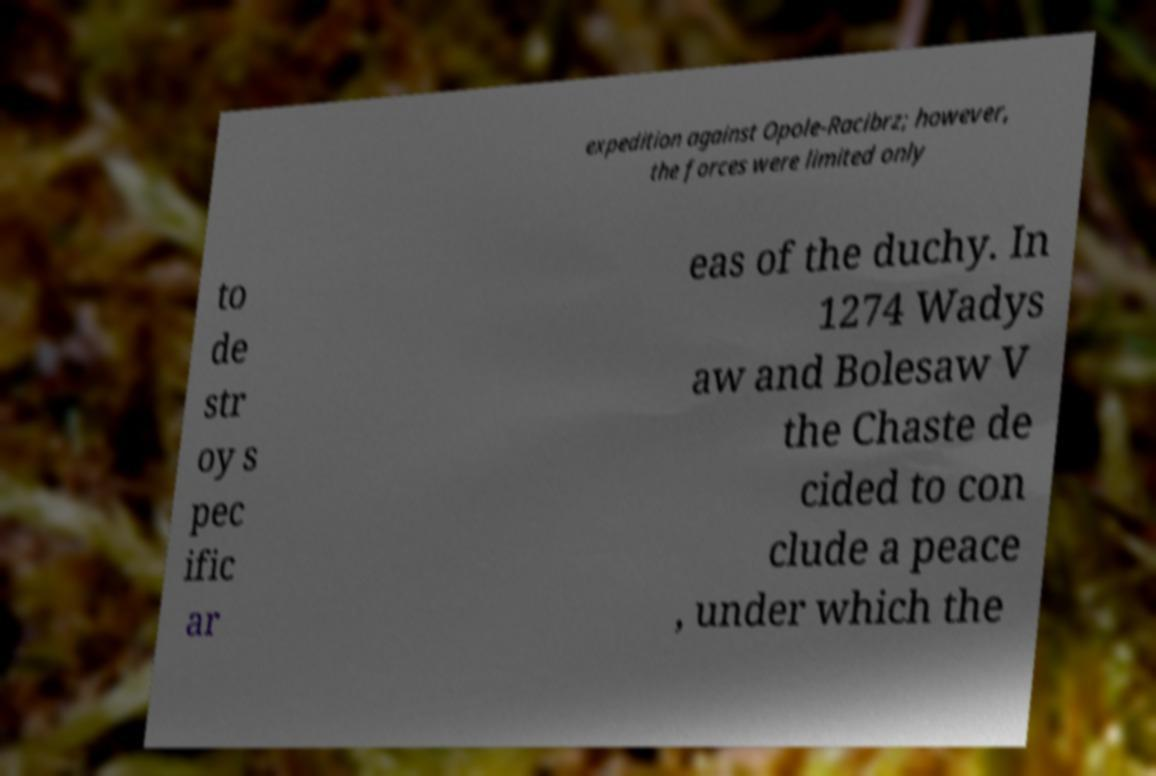There's text embedded in this image that I need extracted. Can you transcribe it verbatim? expedition against Opole-Racibrz; however, the forces were limited only to de str oy s pec ific ar eas of the duchy. In 1274 Wadys aw and Bolesaw V the Chaste de cided to con clude a peace , under which the 